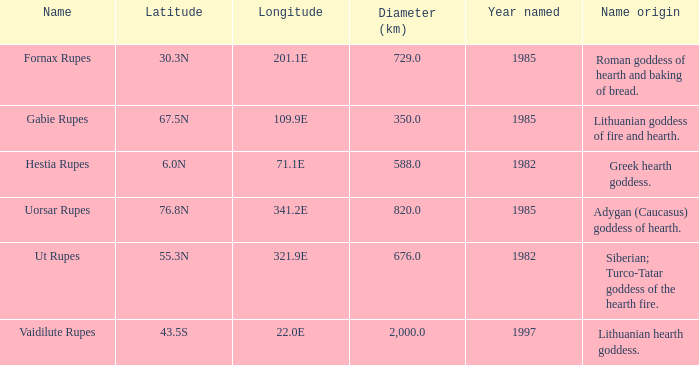At a latitude of 71.1e, what is the feature's name origin? Greek hearth goddess. 